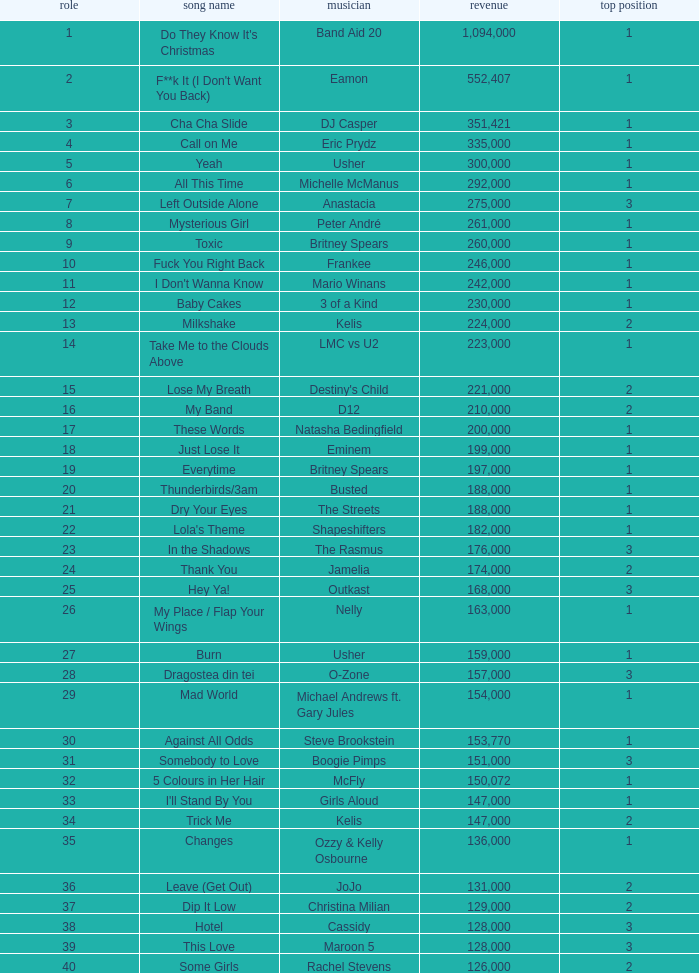What were the sales for Dj Casper when he was in a position lower than 13? 351421.0. 